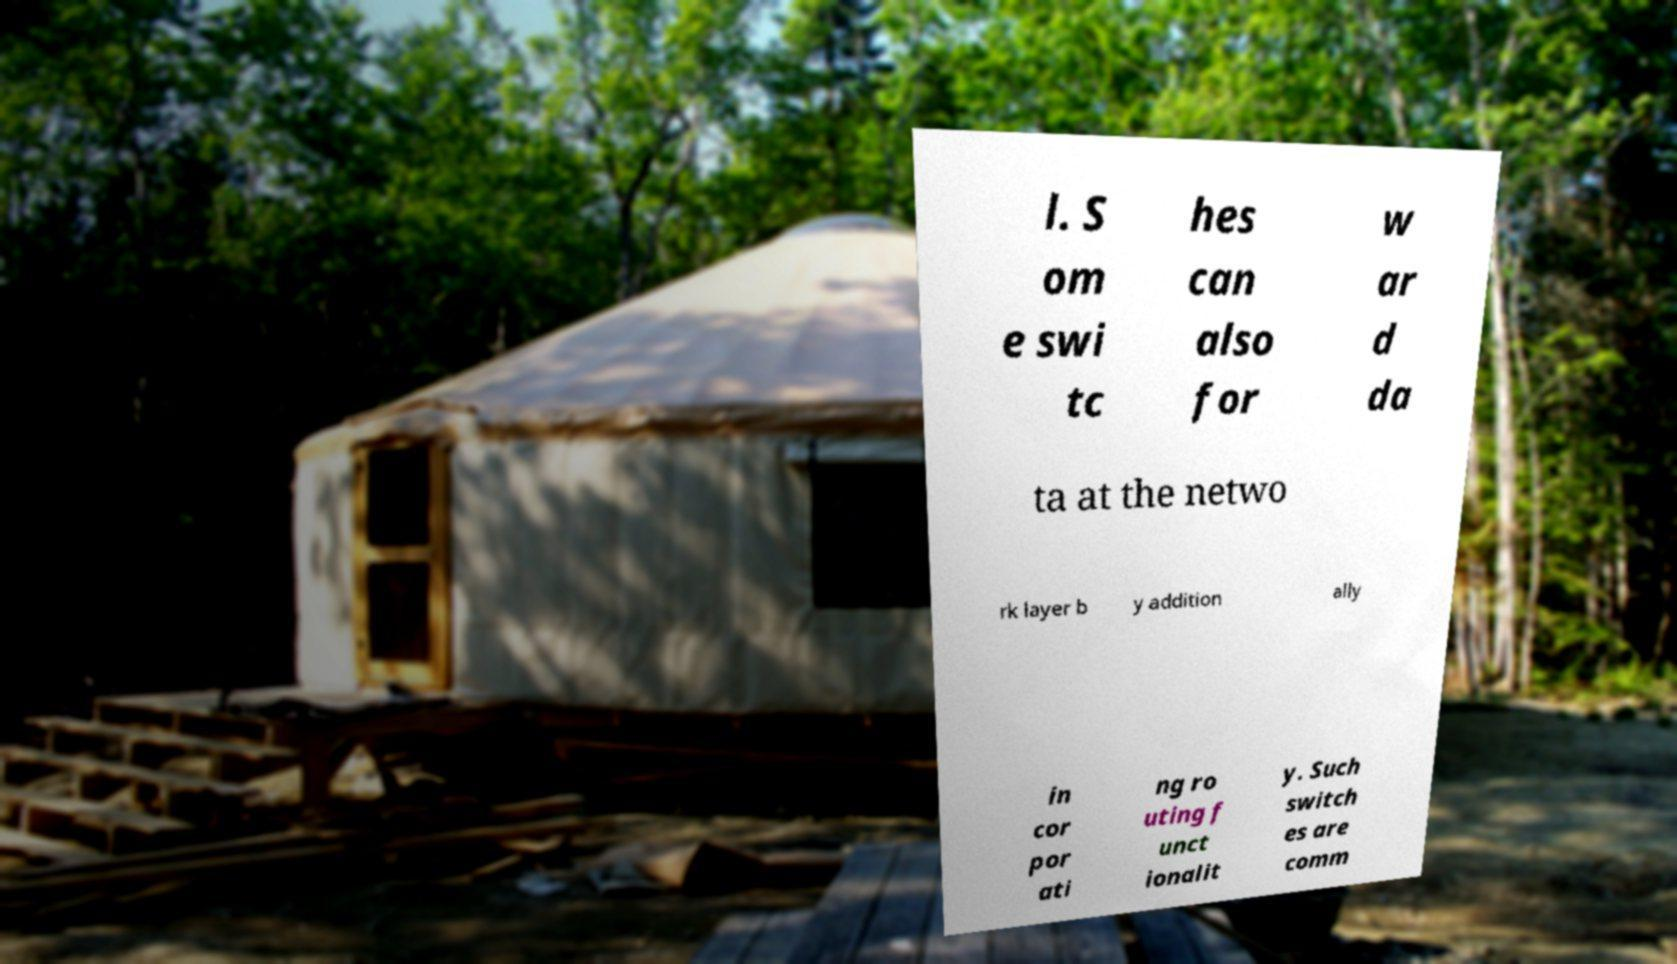There's text embedded in this image that I need extracted. Can you transcribe it verbatim? l. S om e swi tc hes can also for w ar d da ta at the netwo rk layer b y addition ally in cor por ati ng ro uting f unct ionalit y. Such switch es are comm 